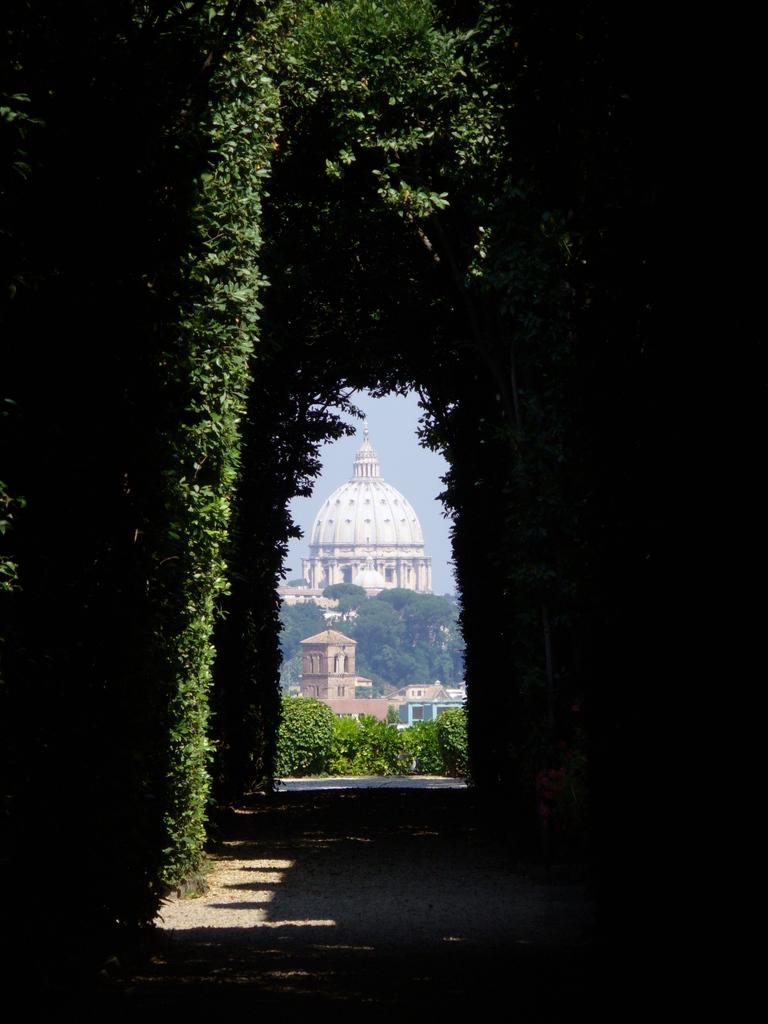What can be seen in the foreground of the picture? There are trees and a walkway in the foreground of the picture. What is located in the middle of the picture? There are plants in the middle of the picture. What is visible in the background of the picture? There are buildings, trees, and the sky in the background of the picture. Can you describe the walkway in the foreground? The walkway in the foreground is a path that people might walk on. What type of tin is used to create the walkway in the image? There is no tin used in the walkway in the image; it is made of a different material. Can you see any veins in the trees in the background of the image? There are no veins visible in the trees in the image, as veins are not a visible part of trees. 